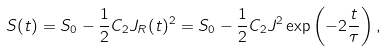Convert formula to latex. <formula><loc_0><loc_0><loc_500><loc_500>S ( t ) = S _ { 0 } - \frac { 1 } { 2 } C _ { 2 } J _ { R } ( t ) ^ { 2 } = S _ { 0 } - \frac { 1 } { 2 } C _ { 2 } J ^ { 2 } \exp \left ( - 2 \frac { t } { \tau } \right ) ,</formula> 